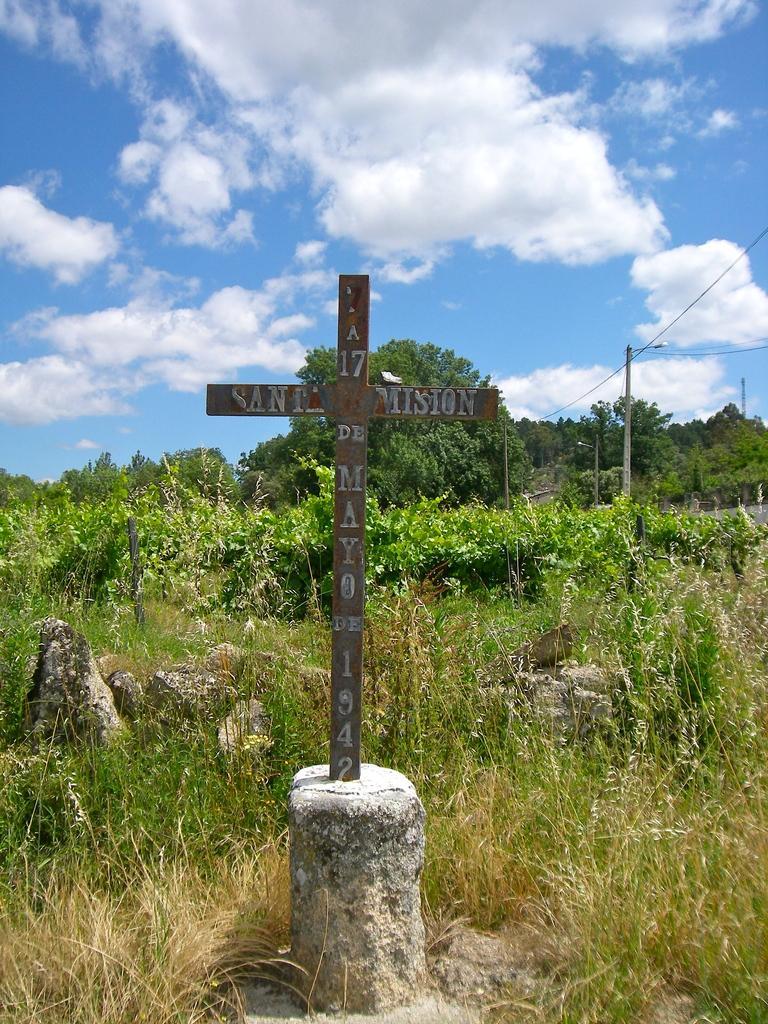Describe this image in one or two sentences. In this picture we can see a cross, stones, trees, pole and in the background we can see the sky with clouds. 